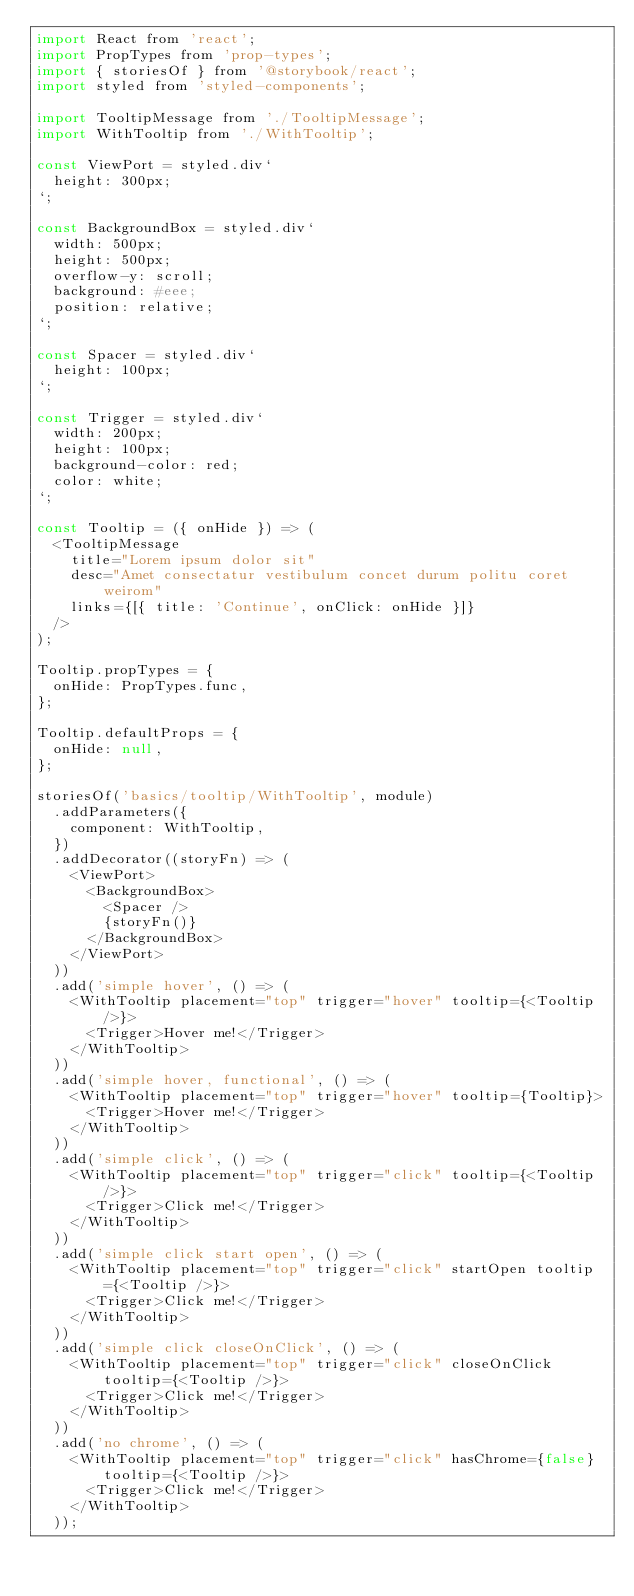<code> <loc_0><loc_0><loc_500><loc_500><_JavaScript_>import React from 'react';
import PropTypes from 'prop-types';
import { storiesOf } from '@storybook/react';
import styled from 'styled-components';

import TooltipMessage from './TooltipMessage';
import WithTooltip from './WithTooltip';

const ViewPort = styled.div`
  height: 300px;
`;

const BackgroundBox = styled.div`
  width: 500px;
  height: 500px;
  overflow-y: scroll;
  background: #eee;
  position: relative;
`;

const Spacer = styled.div`
  height: 100px;
`;

const Trigger = styled.div`
  width: 200px;
  height: 100px;
  background-color: red;
  color: white;
`;

const Tooltip = ({ onHide }) => (
  <TooltipMessage
    title="Lorem ipsum dolor sit"
    desc="Amet consectatur vestibulum concet durum politu coret weirom"
    links={[{ title: 'Continue', onClick: onHide }]}
  />
);

Tooltip.propTypes = {
  onHide: PropTypes.func,
};

Tooltip.defaultProps = {
  onHide: null,
};

storiesOf('basics/tooltip/WithTooltip', module)
  .addParameters({
    component: WithTooltip,
  })
  .addDecorator((storyFn) => (
    <ViewPort>
      <BackgroundBox>
        <Spacer />
        {storyFn()}
      </BackgroundBox>
    </ViewPort>
  ))
  .add('simple hover', () => (
    <WithTooltip placement="top" trigger="hover" tooltip={<Tooltip />}>
      <Trigger>Hover me!</Trigger>
    </WithTooltip>
  ))
  .add('simple hover, functional', () => (
    <WithTooltip placement="top" trigger="hover" tooltip={Tooltip}>
      <Trigger>Hover me!</Trigger>
    </WithTooltip>
  ))
  .add('simple click', () => (
    <WithTooltip placement="top" trigger="click" tooltip={<Tooltip />}>
      <Trigger>Click me!</Trigger>
    </WithTooltip>
  ))
  .add('simple click start open', () => (
    <WithTooltip placement="top" trigger="click" startOpen tooltip={<Tooltip />}>
      <Trigger>Click me!</Trigger>
    </WithTooltip>
  ))
  .add('simple click closeOnClick', () => (
    <WithTooltip placement="top" trigger="click" closeOnClick tooltip={<Tooltip />}>
      <Trigger>Click me!</Trigger>
    </WithTooltip>
  ))
  .add('no chrome', () => (
    <WithTooltip placement="top" trigger="click" hasChrome={false} tooltip={<Tooltip />}>
      <Trigger>Click me!</Trigger>
    </WithTooltip>
  ));
</code> 